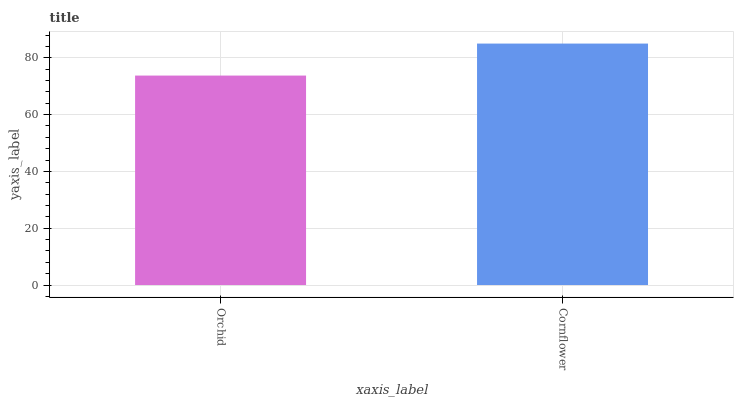Is Orchid the minimum?
Answer yes or no. Yes. Is Cornflower the maximum?
Answer yes or no. Yes. Is Cornflower the minimum?
Answer yes or no. No. Is Cornflower greater than Orchid?
Answer yes or no. Yes. Is Orchid less than Cornflower?
Answer yes or no. Yes. Is Orchid greater than Cornflower?
Answer yes or no. No. Is Cornflower less than Orchid?
Answer yes or no. No. Is Cornflower the high median?
Answer yes or no. Yes. Is Orchid the low median?
Answer yes or no. Yes. Is Orchid the high median?
Answer yes or no. No. Is Cornflower the low median?
Answer yes or no. No. 